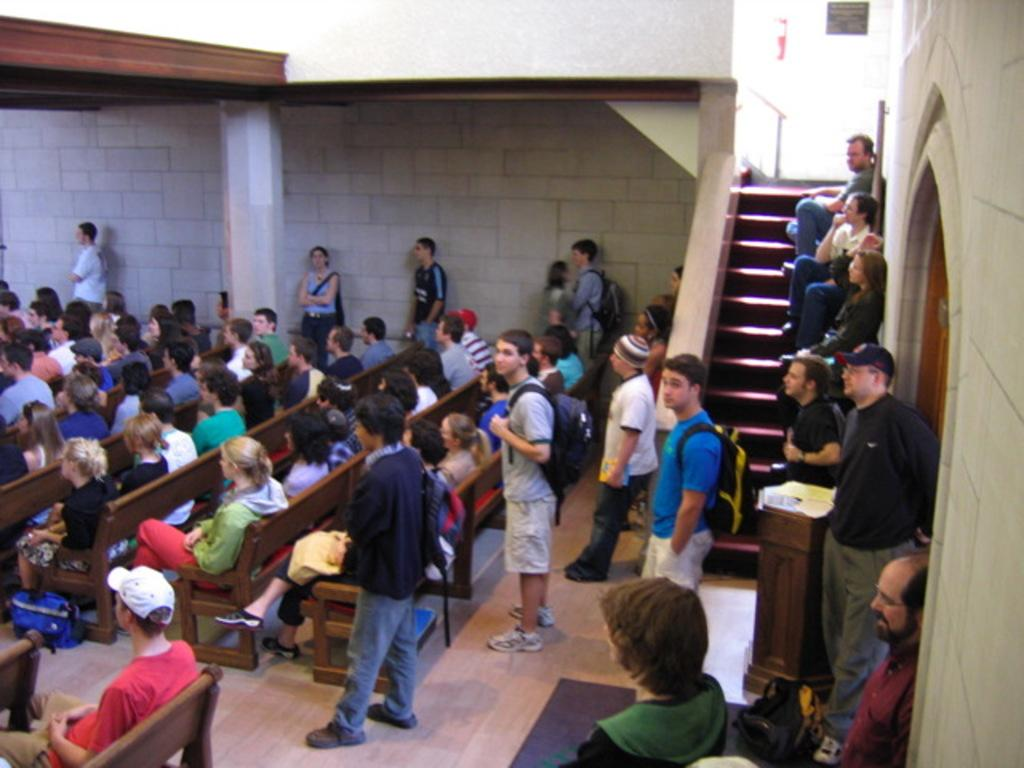Where was the image taken? The image was taken inside a room. What furniture is present in the room? There are benches in the room. What are people doing in the room? People are sitting on the benches. What architectural feature is on the right side of the room? There are stairs on the right side of the room. What are people doing on the stairs? People are sitting on the stairs. What type of birthday magic is being performed on the benches in the image? There is no mention of a birthday or magic in the image; it simply shows people sitting on benches and stairs inside a room. 